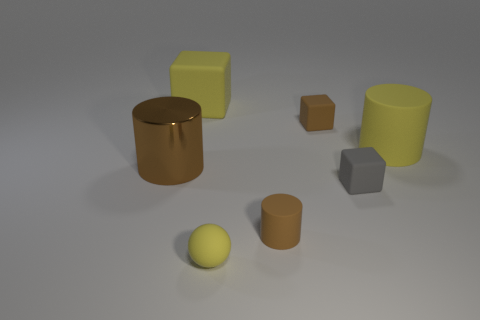Are there any other things that have the same material as the large brown cylinder?
Your answer should be compact. No. What number of metal things have the same shape as the gray rubber thing?
Offer a very short reply. 0. There is a gray thing that is made of the same material as the tiny yellow object; what is its size?
Give a very brief answer. Small. What color is the matte cube left of the small thing in front of the small cylinder?
Your answer should be very brief. Yellow. Do the tiny yellow thing and the big yellow object on the left side of the gray object have the same shape?
Keep it short and to the point. No. What number of balls are the same size as the brown block?
Your answer should be compact. 1. There is another big yellow object that is the same shape as the big metallic object; what material is it?
Your answer should be compact. Rubber. Does the small object that is in front of the small brown rubber cylinder have the same color as the tiny block in front of the large rubber cylinder?
Give a very brief answer. No. What is the shape of the yellow object that is right of the small gray cube?
Provide a succinct answer. Cylinder. The big matte cube is what color?
Make the answer very short. Yellow. 